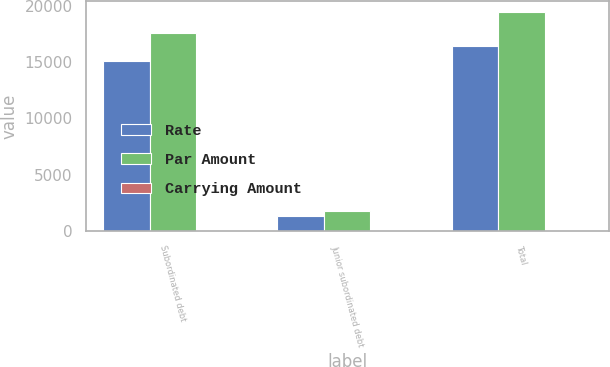<chart> <loc_0><loc_0><loc_500><loc_500><stacked_bar_chart><ecel><fcel>Subordinated debt<fcel>Junior subordinated debt<fcel>Total<nl><fcel>Rate<fcel>15058<fcel>1360<fcel>16418<nl><fcel>Par Amount<fcel>17604<fcel>1809<fcel>19413<nl><fcel>Carrying Amount<fcel>4.29<fcel>5.7<fcel>4.41<nl></chart> 